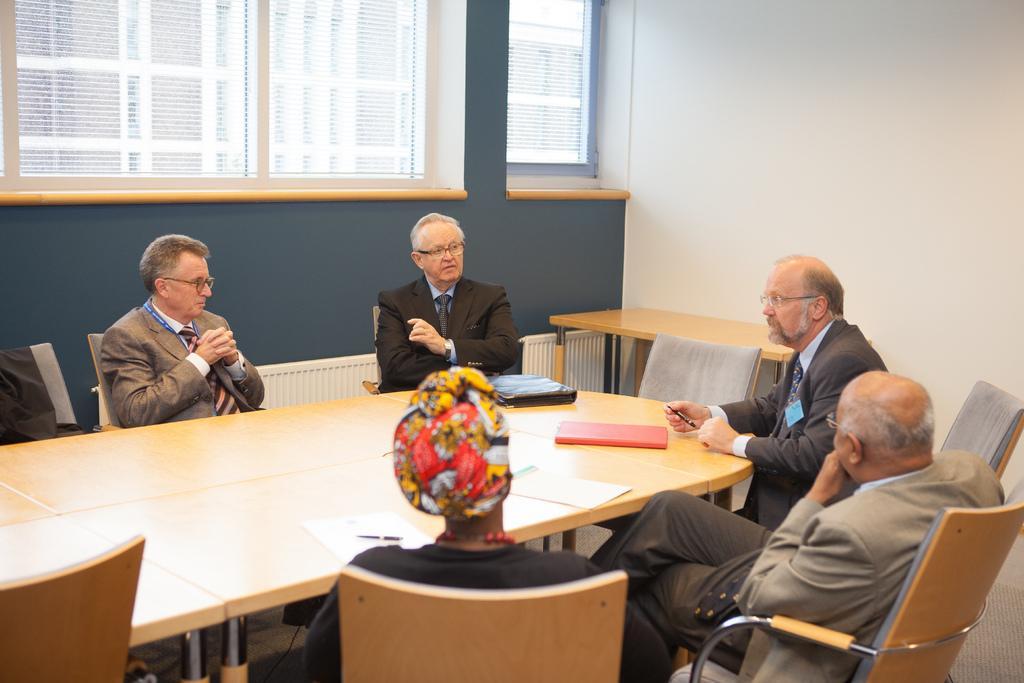Can you describe this image briefly? In the image there are few people sitting on the chairs. In front of them there is a table with files and papers. Behind them there is a table. In the background there is a wall with windows and curtains. 